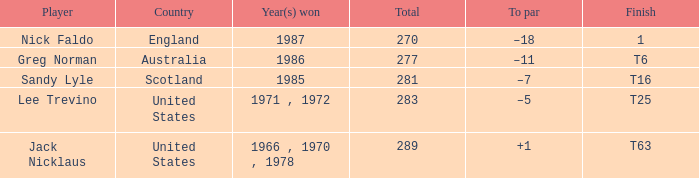Which nation has a sum exceeding 270, featuring sandy lyle as the participant? Scotland. 